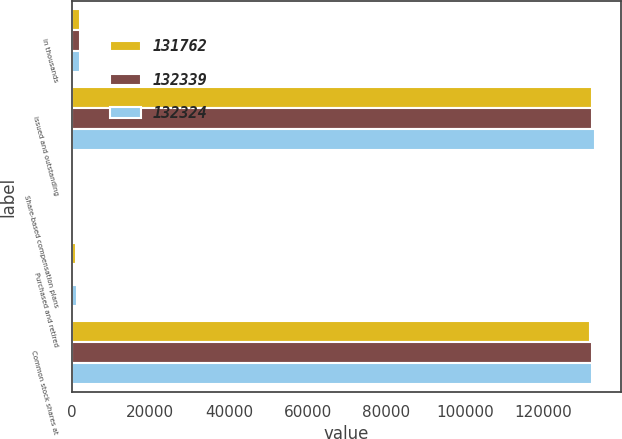Convert chart to OTSL. <chart><loc_0><loc_0><loc_500><loc_500><stacked_bar_chart><ecel><fcel>in thousands<fcel>issued and outstanding<fcel>Share-based compensation plans<fcel>Purchased and retired<fcel>Common stock shares at<nl><fcel>131762<fcel>2018<fcel>132324<fcel>630<fcel>1192<fcel>131762<nl><fcel>132339<fcel>2017<fcel>132339<fcel>495<fcel>510<fcel>132324<nl><fcel>132324<fcel>2016<fcel>133172<fcel>594<fcel>1427<fcel>132339<nl></chart> 